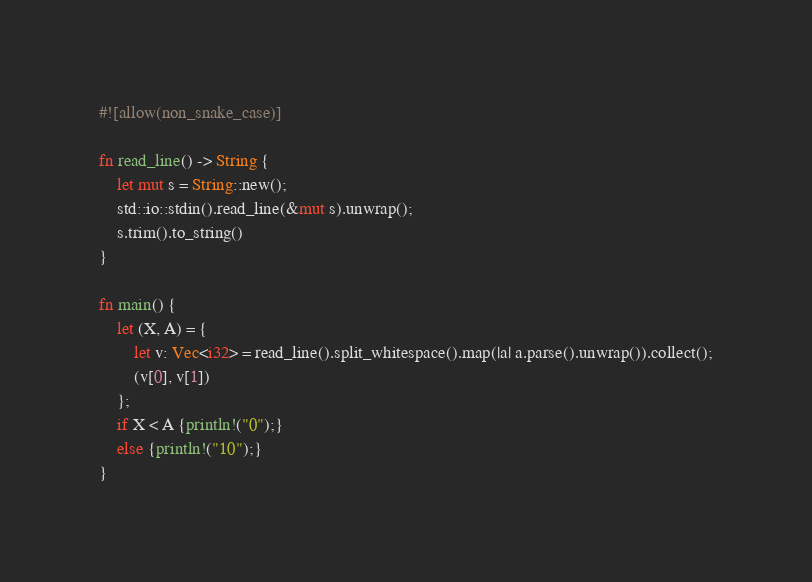<code> <loc_0><loc_0><loc_500><loc_500><_Rust_>#![allow(non_snake_case)]

fn read_line() -> String {
    let mut s = String::new();
    std::io::stdin().read_line(&mut s).unwrap();
    s.trim().to_string()
}

fn main() {
    let (X, A) = {
        let v: Vec<i32> = read_line().split_whitespace().map(|a| a.parse().unwrap()).collect();
        (v[0], v[1])
    };
    if X < A {println!("0");}
    else {println!("10");}
}
</code> 